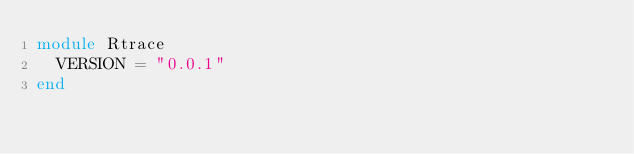Convert code to text. <code><loc_0><loc_0><loc_500><loc_500><_Ruby_>module Rtrace
  VERSION = "0.0.1"
end
</code> 